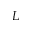<formula> <loc_0><loc_0><loc_500><loc_500>L</formula> 